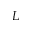<formula> <loc_0><loc_0><loc_500><loc_500>L</formula> 